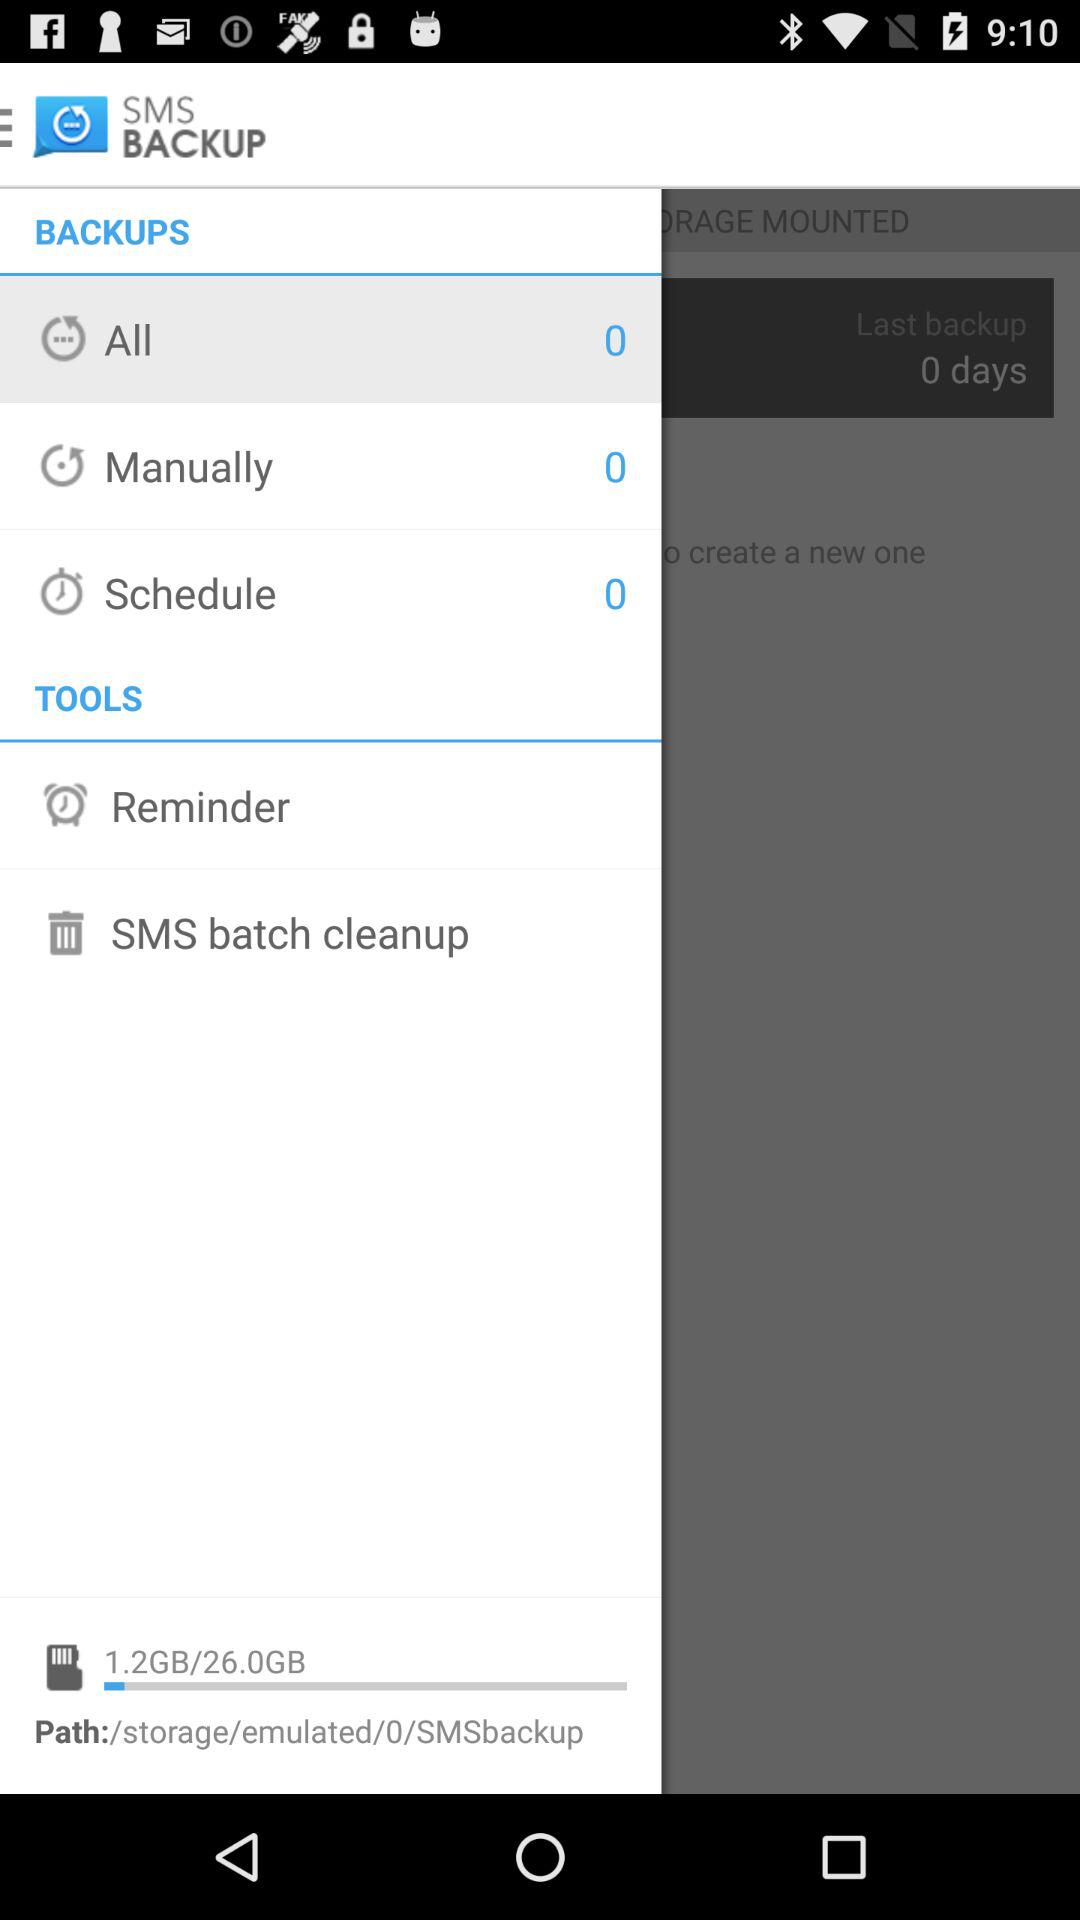How many days have passed since the last backup?
Answer the question using a single word or phrase. 0 days 